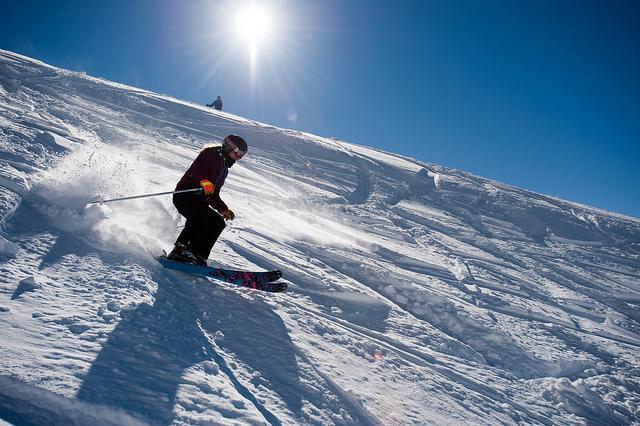How many cars are waiting at the cross walk?
Give a very brief answer. 0. 